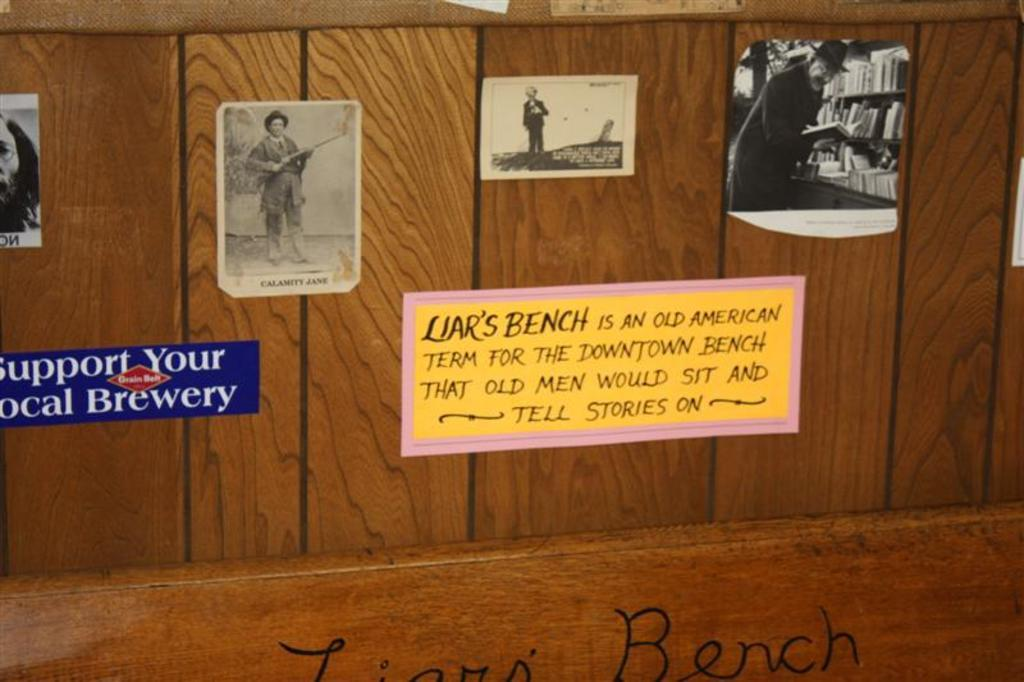<image>
Present a compact description of the photo's key features. Liar's Bench signs on a wall with pictures and a sign saying Support your local brewery. 